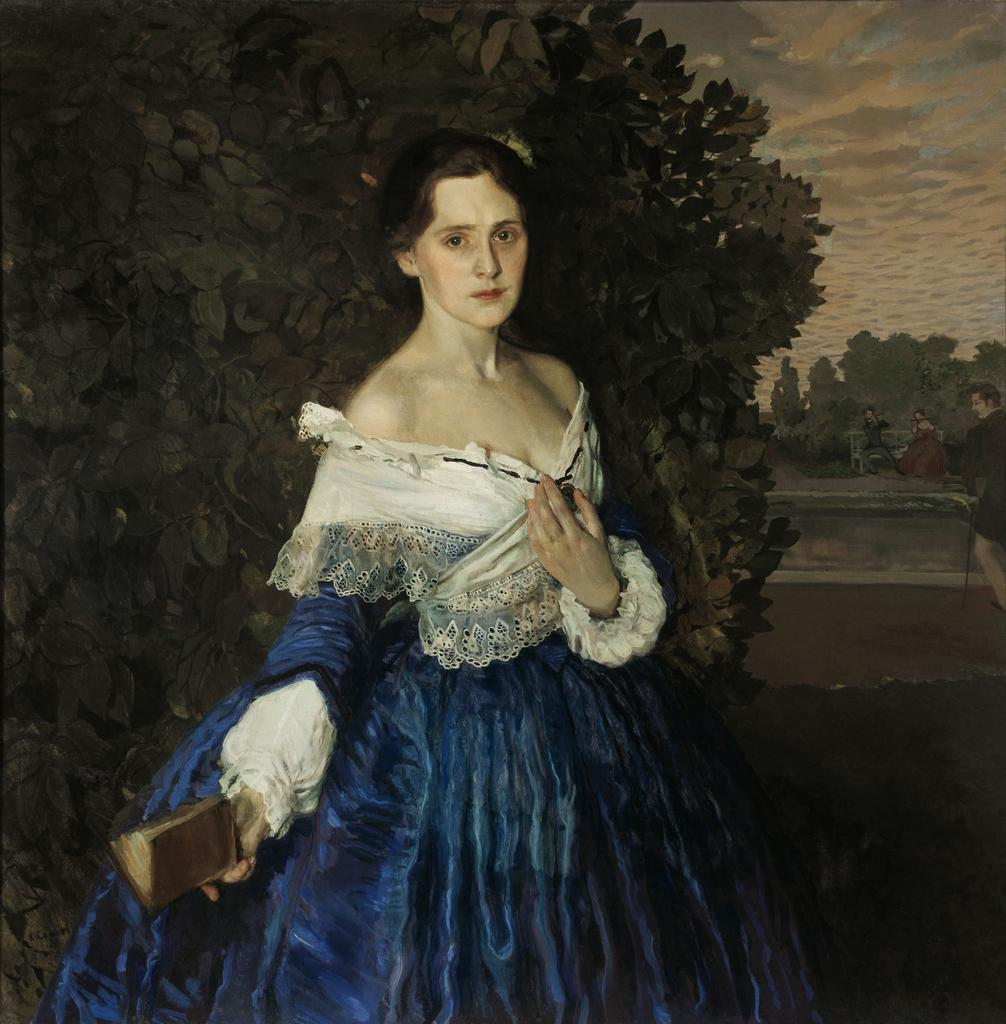What is the main subject of the painting? The main subject of the painting is a lady. What can be seen in the background of the painting? There are trees and sky visible in the background of the painting. Are there any other figures or objects in the painting besides the lady? Yes, there are people in the background of the painting. What type of prose is being recited by the ducks in the painting? There are no ducks present in the painting, so there is no prose being recited by them. 